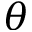<formula> <loc_0><loc_0><loc_500><loc_500>\theta</formula> 